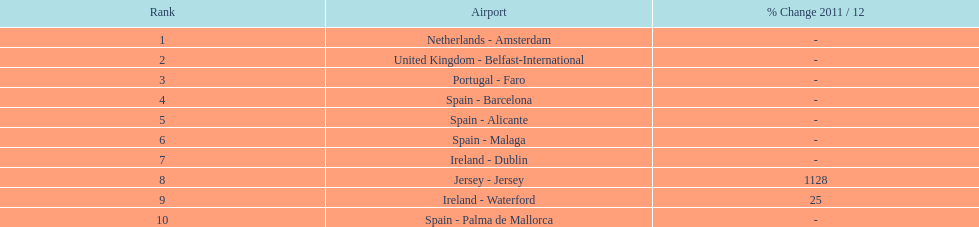How many airports are cataloged? 10. 